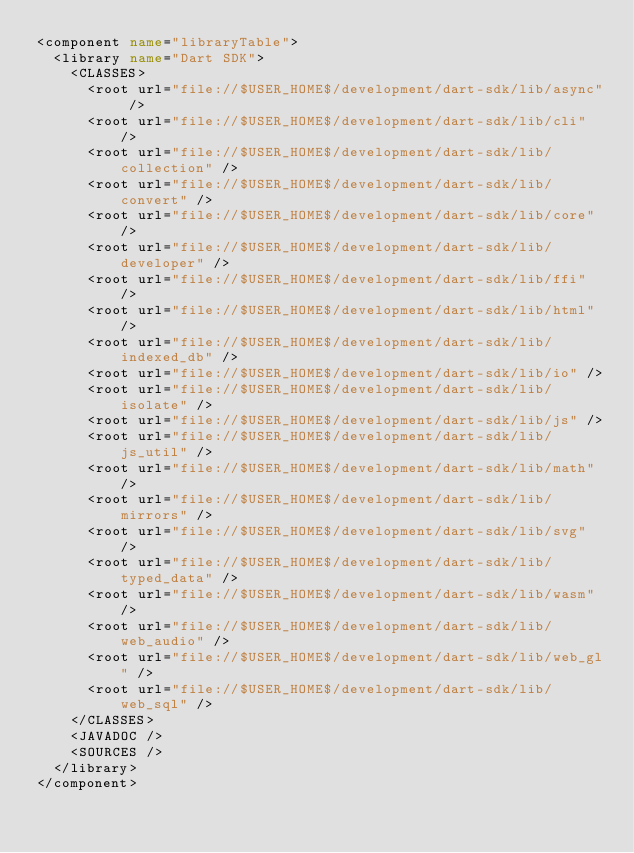<code> <loc_0><loc_0><loc_500><loc_500><_XML_><component name="libraryTable">
  <library name="Dart SDK">
    <CLASSES>
      <root url="file://$USER_HOME$/development/dart-sdk/lib/async" />
      <root url="file://$USER_HOME$/development/dart-sdk/lib/cli" />
      <root url="file://$USER_HOME$/development/dart-sdk/lib/collection" />
      <root url="file://$USER_HOME$/development/dart-sdk/lib/convert" />
      <root url="file://$USER_HOME$/development/dart-sdk/lib/core" />
      <root url="file://$USER_HOME$/development/dart-sdk/lib/developer" />
      <root url="file://$USER_HOME$/development/dart-sdk/lib/ffi" />
      <root url="file://$USER_HOME$/development/dart-sdk/lib/html" />
      <root url="file://$USER_HOME$/development/dart-sdk/lib/indexed_db" />
      <root url="file://$USER_HOME$/development/dart-sdk/lib/io" />
      <root url="file://$USER_HOME$/development/dart-sdk/lib/isolate" />
      <root url="file://$USER_HOME$/development/dart-sdk/lib/js" />
      <root url="file://$USER_HOME$/development/dart-sdk/lib/js_util" />
      <root url="file://$USER_HOME$/development/dart-sdk/lib/math" />
      <root url="file://$USER_HOME$/development/dart-sdk/lib/mirrors" />
      <root url="file://$USER_HOME$/development/dart-sdk/lib/svg" />
      <root url="file://$USER_HOME$/development/dart-sdk/lib/typed_data" />
      <root url="file://$USER_HOME$/development/dart-sdk/lib/wasm" />
      <root url="file://$USER_HOME$/development/dart-sdk/lib/web_audio" />
      <root url="file://$USER_HOME$/development/dart-sdk/lib/web_gl" />
      <root url="file://$USER_HOME$/development/dart-sdk/lib/web_sql" />
    </CLASSES>
    <JAVADOC />
    <SOURCES />
  </library>
</component></code> 